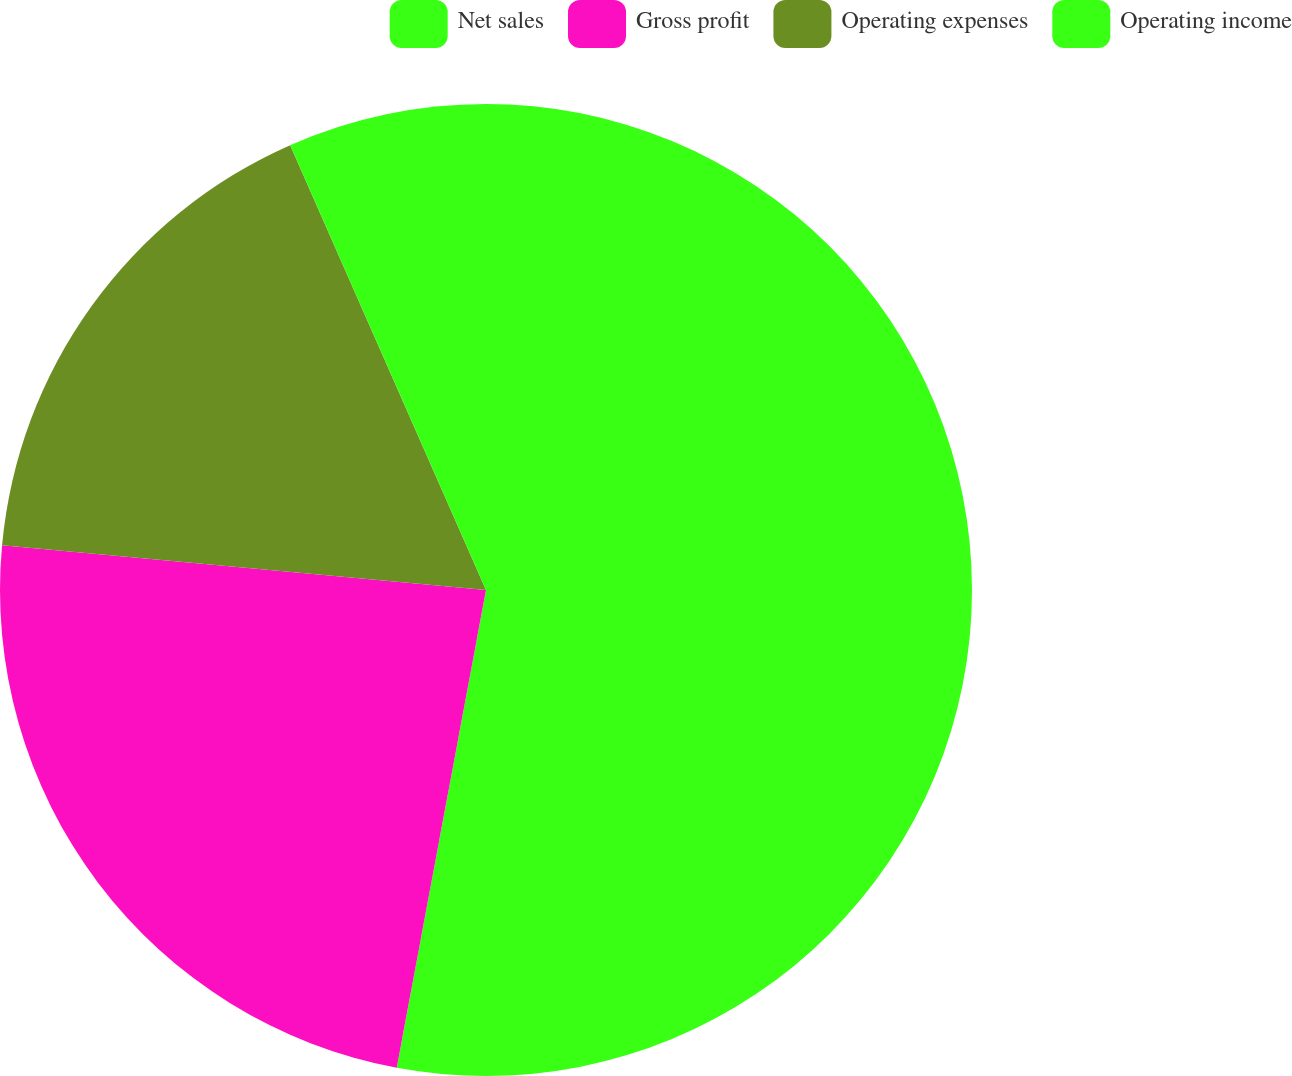<chart> <loc_0><loc_0><loc_500><loc_500><pie_chart><fcel>Net sales<fcel>Gross profit<fcel>Operating expenses<fcel>Operating income<nl><fcel>52.94%<fcel>23.53%<fcel>16.93%<fcel>6.6%<nl></chart> 